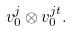<formula> <loc_0><loc_0><loc_500><loc_500>v _ { 0 } ^ { j } \otimes v _ { 0 } ^ { j t } .</formula> 